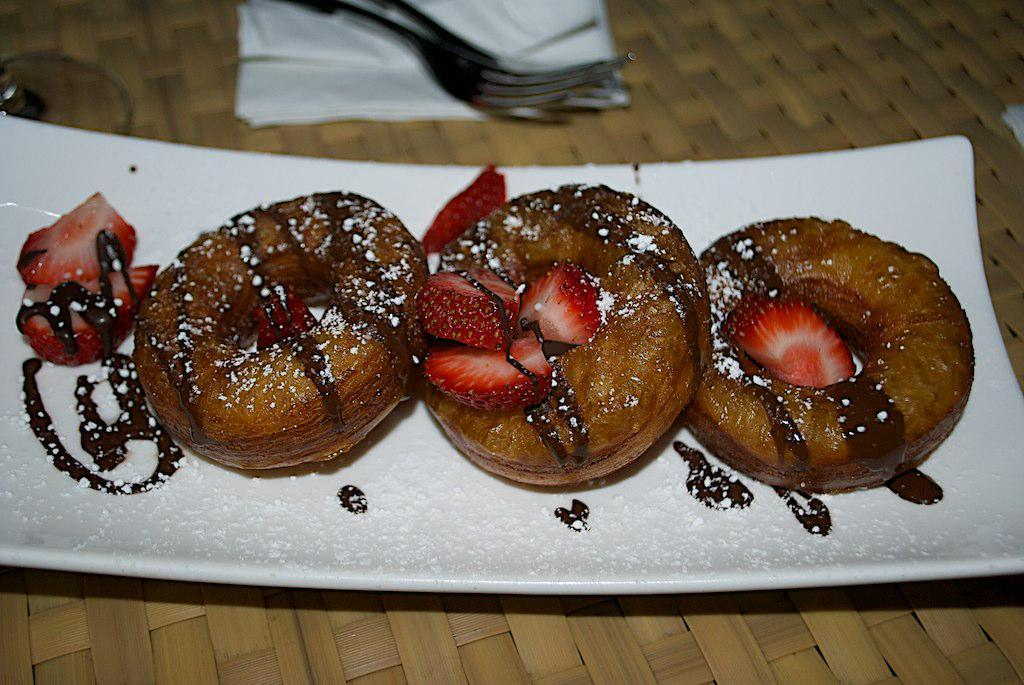What piece of furniture is present in the image? There is a table in the image. What is placed item is placed on the table? There is a plate on the table. What type of food can be seen on the table? There are strawberries and donuts on the table. What utensils are available on the table? There are forks on the table. What can be used for wiping or cleaning on the table? There are napkins on the table. Can you locate the map on the table in the image? There is no map present in the image; the table contains a plate, strawberries, donuts, forks, and napkins. 